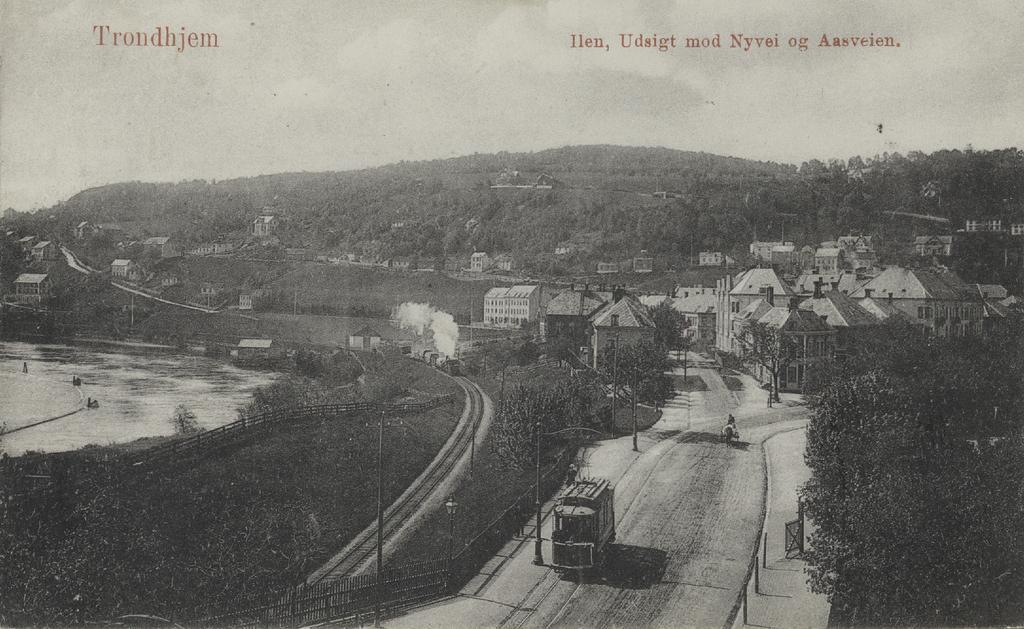Can you describe this image briefly? It is the black and white image in which we can see the view of the city. In the middle there is a road on which there are vehicles. There are buildings on either side of the road. On the left side there is a railway track. Beside the railway track there are so many plants. On the left side there is water. In the background there are hills on which there are trees. 